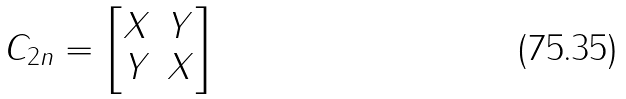Convert formula to latex. <formula><loc_0><loc_0><loc_500><loc_500>C _ { 2 n } = \begin{bmatrix} X & Y \\ Y & X \end{bmatrix}</formula> 